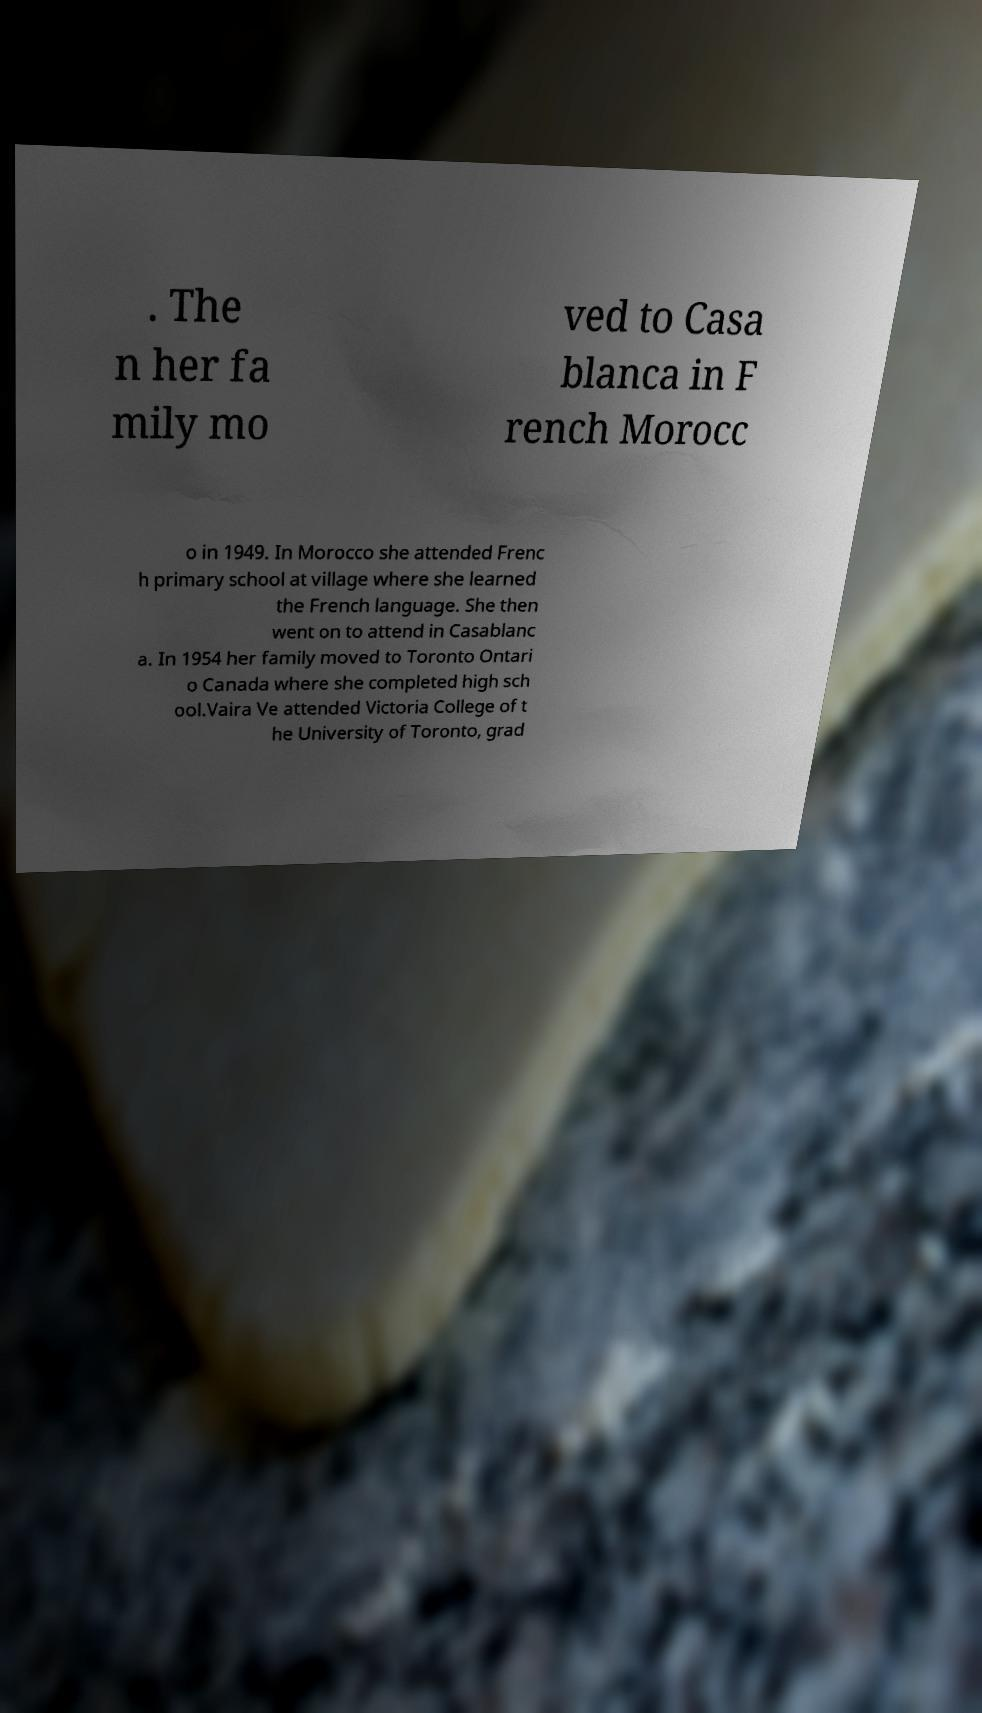There's text embedded in this image that I need extracted. Can you transcribe it verbatim? . The n her fa mily mo ved to Casa blanca in F rench Morocc o in 1949. In Morocco she attended Frenc h primary school at village where she learned the French language. She then went on to attend in Casablanc a. In 1954 her family moved to Toronto Ontari o Canada where she completed high sch ool.Vaira Ve attended Victoria College of t he University of Toronto, grad 